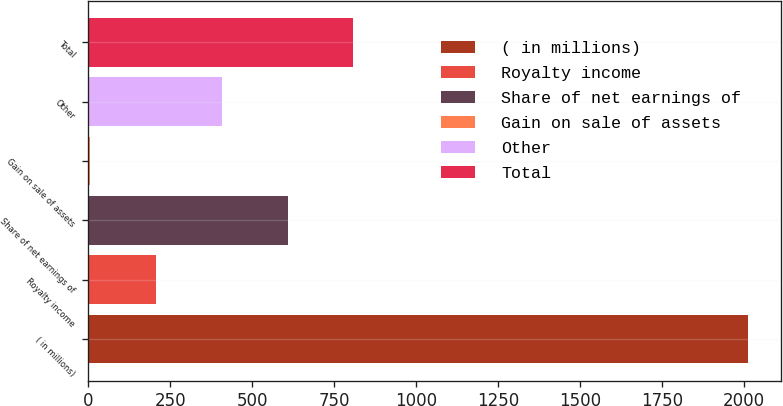Convert chart. <chart><loc_0><loc_0><loc_500><loc_500><bar_chart><fcel>( in millions)<fcel>Royalty income<fcel>Share of net earnings of<fcel>Gain on sale of assets<fcel>Other<fcel>Total<nl><fcel>2014<fcel>206.8<fcel>608.4<fcel>6<fcel>407.6<fcel>809.2<nl></chart> 